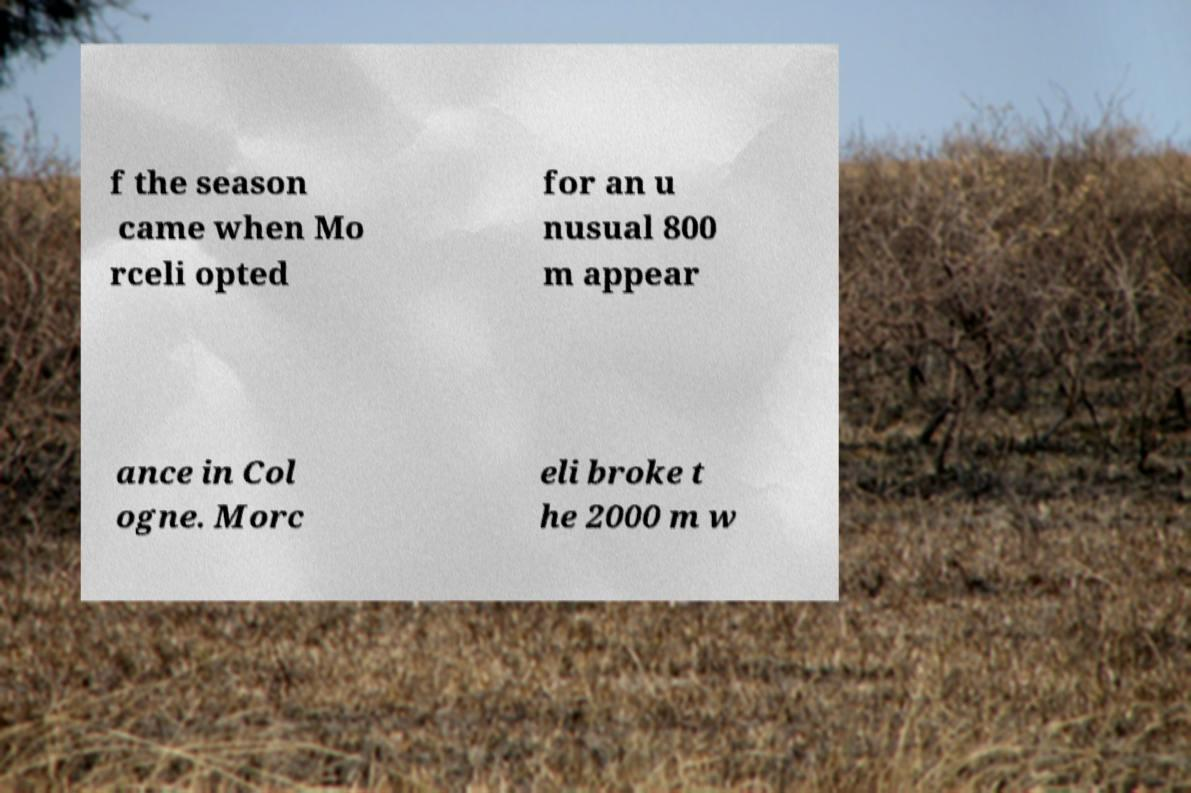Please read and relay the text visible in this image. What does it say? f the season came when Mo rceli opted for an u nusual 800 m appear ance in Col ogne. Morc eli broke t he 2000 m w 